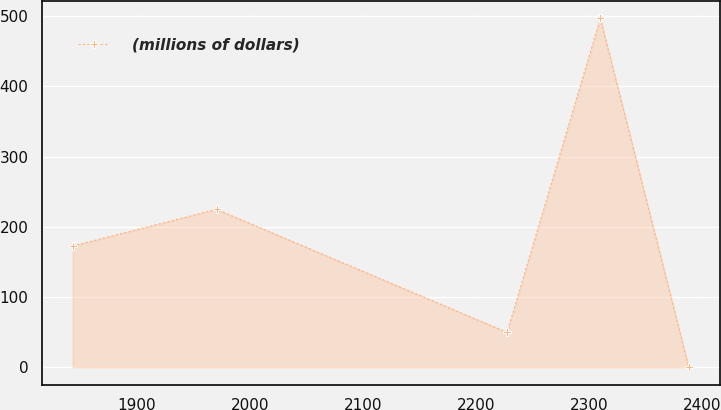Convert chart to OTSL. <chart><loc_0><loc_0><loc_500><loc_500><line_chart><ecel><fcel>(millions of dollars)<nl><fcel>1843.07<fcel>172.65<nl><fcel>1970.36<fcel>224.83<nl><fcel>2227.4<fcel>49.74<nl><fcel>2309.9<fcel>496.41<nl><fcel>2388.12<fcel>0.11<nl></chart> 